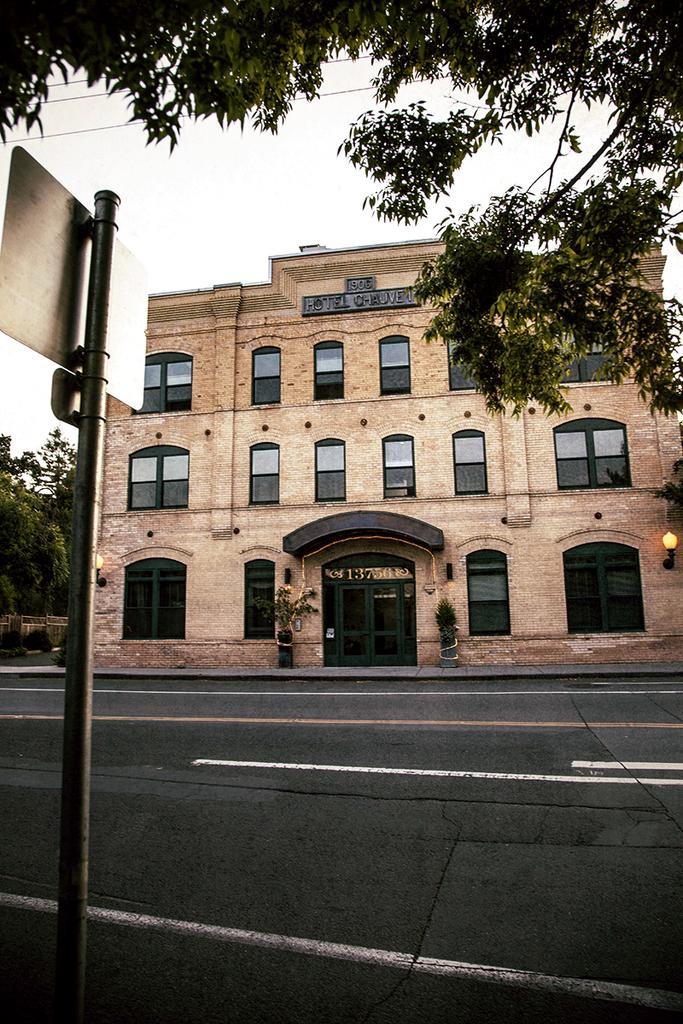Could you give a brief overview of what you see in this image? This picture is clicked outside. In the foreground we can see the board is attached to the metal rod. In the center we can see the concrete road and we can see the building, wall mounted lamps, green leaves, and in the background we can see the sky, trees, plants and some other items. 